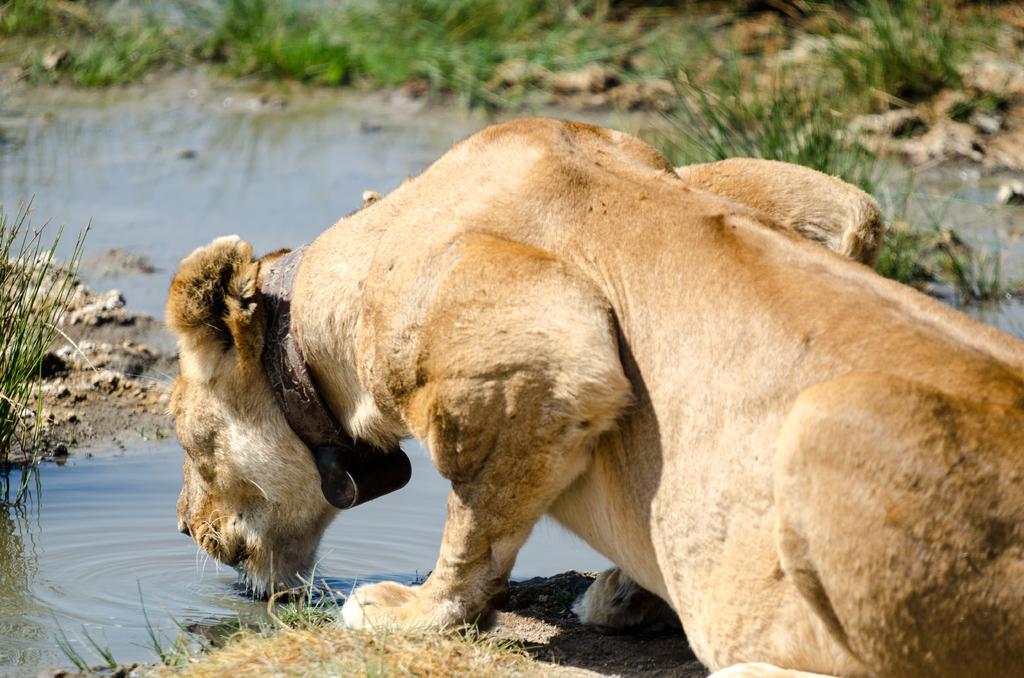Can you describe this image briefly? In this image there is a lion which is drinking the water. In the background there is grass. At the bottom there is sand. 